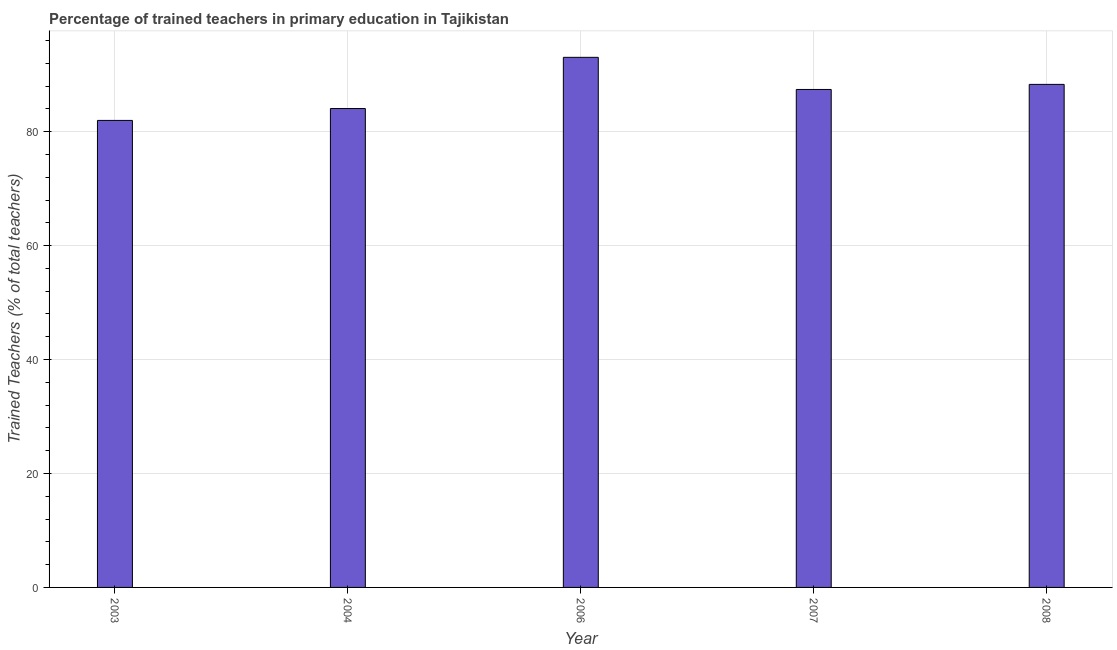Does the graph contain any zero values?
Keep it short and to the point. No. Does the graph contain grids?
Provide a succinct answer. Yes. What is the title of the graph?
Your response must be concise. Percentage of trained teachers in primary education in Tajikistan. What is the label or title of the X-axis?
Give a very brief answer. Year. What is the label or title of the Y-axis?
Your answer should be very brief. Trained Teachers (% of total teachers). What is the percentage of trained teachers in 2007?
Offer a very short reply. 87.41. Across all years, what is the maximum percentage of trained teachers?
Offer a very short reply. 93.05. Across all years, what is the minimum percentage of trained teachers?
Offer a very short reply. 81.98. In which year was the percentage of trained teachers maximum?
Make the answer very short. 2006. What is the sum of the percentage of trained teachers?
Your response must be concise. 434.79. What is the difference between the percentage of trained teachers in 2006 and 2007?
Provide a succinct answer. 5.64. What is the average percentage of trained teachers per year?
Offer a very short reply. 86.96. What is the median percentage of trained teachers?
Your answer should be compact. 87.41. What is the ratio of the percentage of trained teachers in 2003 to that in 2007?
Offer a very short reply. 0.94. Is the percentage of trained teachers in 2004 less than that in 2006?
Your answer should be very brief. Yes. Is the difference between the percentage of trained teachers in 2004 and 2007 greater than the difference between any two years?
Ensure brevity in your answer.  No. What is the difference between the highest and the second highest percentage of trained teachers?
Offer a very short reply. 4.75. What is the difference between the highest and the lowest percentage of trained teachers?
Make the answer very short. 11.07. How many bars are there?
Your answer should be very brief. 5. How many years are there in the graph?
Provide a short and direct response. 5. Are the values on the major ticks of Y-axis written in scientific E-notation?
Give a very brief answer. No. What is the Trained Teachers (% of total teachers) in 2003?
Your response must be concise. 81.98. What is the Trained Teachers (% of total teachers) in 2004?
Ensure brevity in your answer.  84.06. What is the Trained Teachers (% of total teachers) in 2006?
Make the answer very short. 93.05. What is the Trained Teachers (% of total teachers) in 2007?
Your answer should be very brief. 87.41. What is the Trained Teachers (% of total teachers) of 2008?
Your response must be concise. 88.3. What is the difference between the Trained Teachers (% of total teachers) in 2003 and 2004?
Offer a terse response. -2.09. What is the difference between the Trained Teachers (% of total teachers) in 2003 and 2006?
Offer a very short reply. -11.07. What is the difference between the Trained Teachers (% of total teachers) in 2003 and 2007?
Keep it short and to the point. -5.43. What is the difference between the Trained Teachers (% of total teachers) in 2003 and 2008?
Make the answer very short. -6.32. What is the difference between the Trained Teachers (% of total teachers) in 2004 and 2006?
Provide a succinct answer. -8.99. What is the difference between the Trained Teachers (% of total teachers) in 2004 and 2007?
Provide a short and direct response. -3.35. What is the difference between the Trained Teachers (% of total teachers) in 2004 and 2008?
Your response must be concise. -4.24. What is the difference between the Trained Teachers (% of total teachers) in 2006 and 2007?
Keep it short and to the point. 5.64. What is the difference between the Trained Teachers (% of total teachers) in 2006 and 2008?
Offer a terse response. 4.75. What is the difference between the Trained Teachers (% of total teachers) in 2007 and 2008?
Provide a succinct answer. -0.89. What is the ratio of the Trained Teachers (% of total teachers) in 2003 to that in 2004?
Provide a short and direct response. 0.97. What is the ratio of the Trained Teachers (% of total teachers) in 2003 to that in 2006?
Offer a terse response. 0.88. What is the ratio of the Trained Teachers (% of total teachers) in 2003 to that in 2007?
Offer a terse response. 0.94. What is the ratio of the Trained Teachers (% of total teachers) in 2003 to that in 2008?
Offer a very short reply. 0.93. What is the ratio of the Trained Teachers (% of total teachers) in 2004 to that in 2006?
Offer a very short reply. 0.9. What is the ratio of the Trained Teachers (% of total teachers) in 2006 to that in 2007?
Your response must be concise. 1.06. What is the ratio of the Trained Teachers (% of total teachers) in 2006 to that in 2008?
Offer a very short reply. 1.05. What is the ratio of the Trained Teachers (% of total teachers) in 2007 to that in 2008?
Make the answer very short. 0.99. 